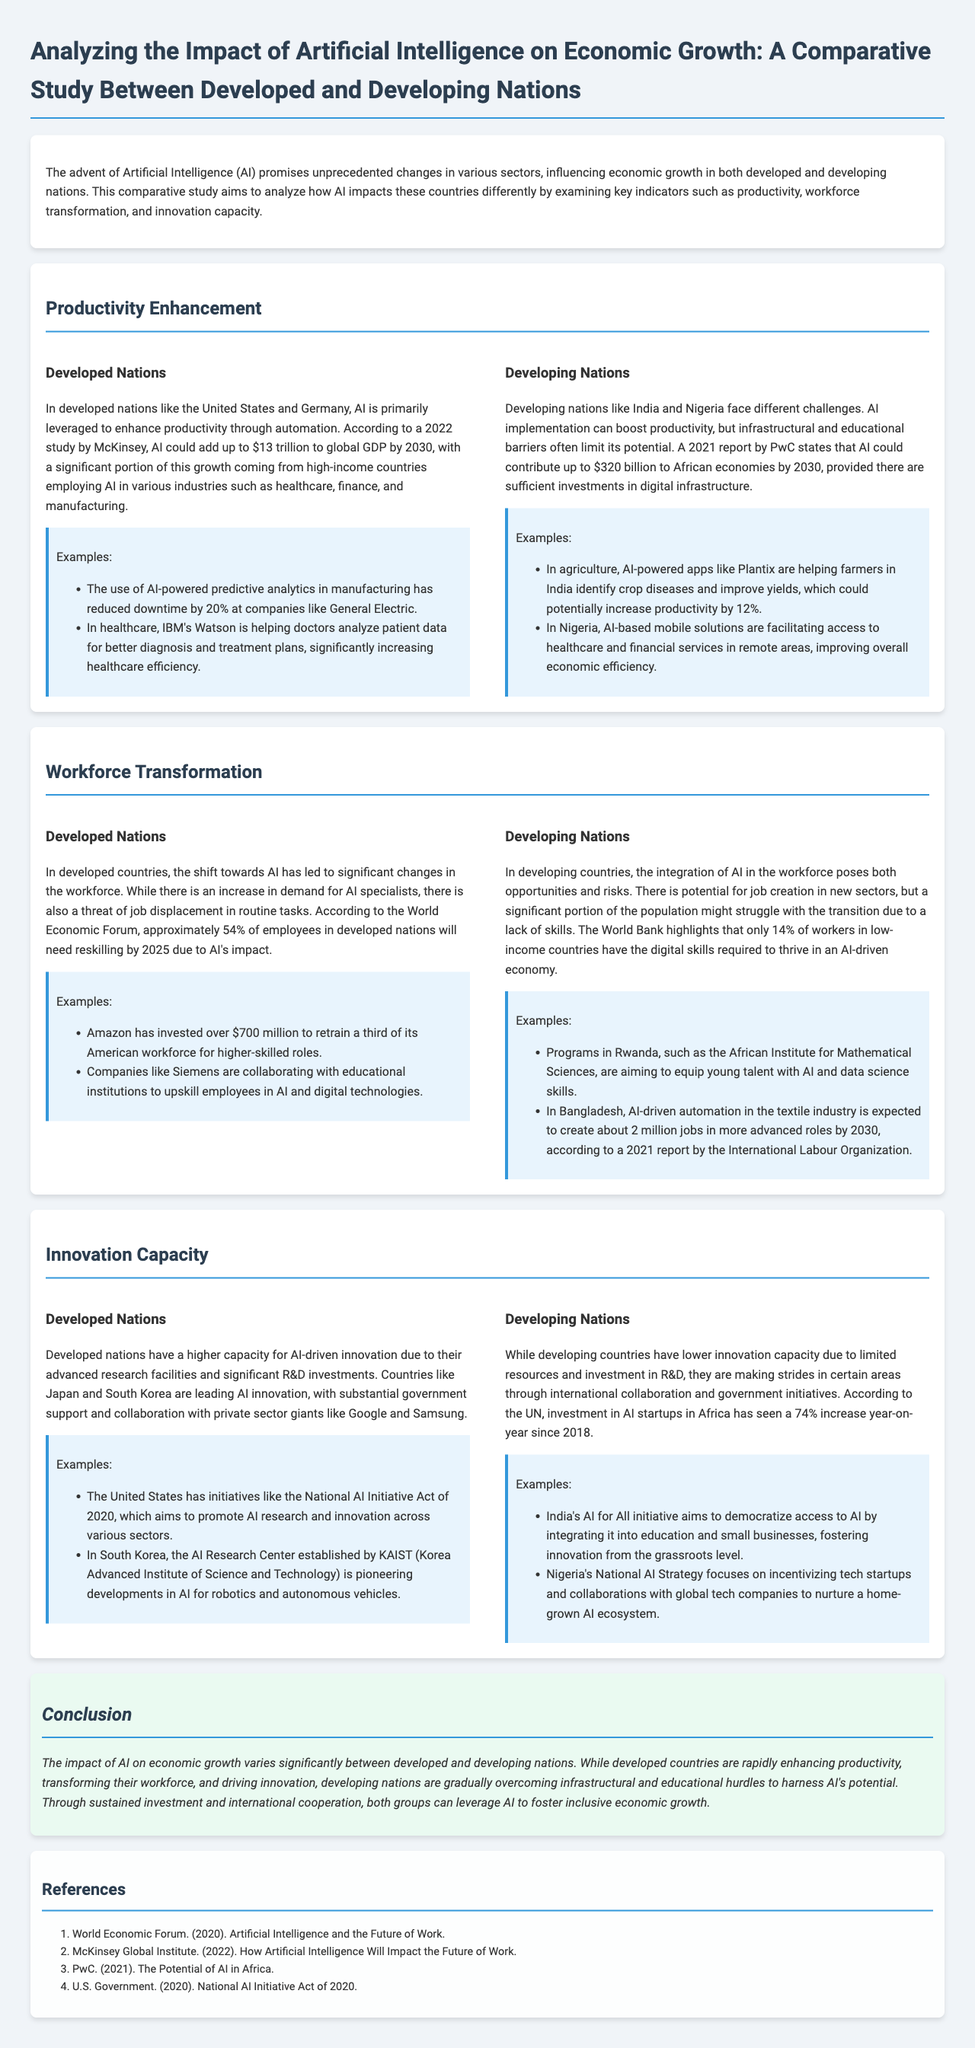What is the main focus of the study? The study focuses on the impact of AI on economic growth in developed and developing nations.
Answer: AI on economic growth What percentage of employees in developed nations will need reskilling by 2025? The World Economic Forum states approximately 54% of employees will require reskilling by 2025 due to AI's impact.
Answer: 54% What is the expected contribution of AI to African economies by 2030? According to a 2021 report by PwC, AI could contribute up to $320 billion to African economies by 2030.
Answer: $320 billion What initiative does the United States have to promote AI research and innovation? The document mentions the National AI Initiative Act of 2020 as a significant initiative in the U.S.
Answer: National AI Initiative Act of 2020 Which company invested over $700 million to retrain their workforce in the United States? Amazon is noted for its investment of over $700 million to retrain a third of its American workforce.
Answer: Amazon What two countries are listed as developed nations in the study? The study mentions the United States and Germany as examples of developed nations.
Answer: United States, Germany What is the potential increase in productivity for farmers in India using AI-powered apps? The document states that AI-powered apps like Plantix could potentially increase productivity by 12%.
Answer: 12% What strategy is Nigeria implementing to foster an AI ecosystem? Nigeria's National AI Strategy focuses on incentivizing tech startups and collaborations with global tech companies.
Answer: National AI Strategy What is the conclusion regarding the impact of AI on economic growth? The conclusion summarizes that the impact of AI varies significantly between developed and developing nations.
Answer: Varies significantly 